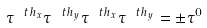<formula> <loc_0><loc_0><loc_500><loc_500>\tau ^ { \ t h _ { x } } \tau ^ { \ t h _ { y } } \tau ^ { \ t h _ { x } } \tau ^ { \ t h _ { y } } = \pm \tau ^ { 0 }</formula> 